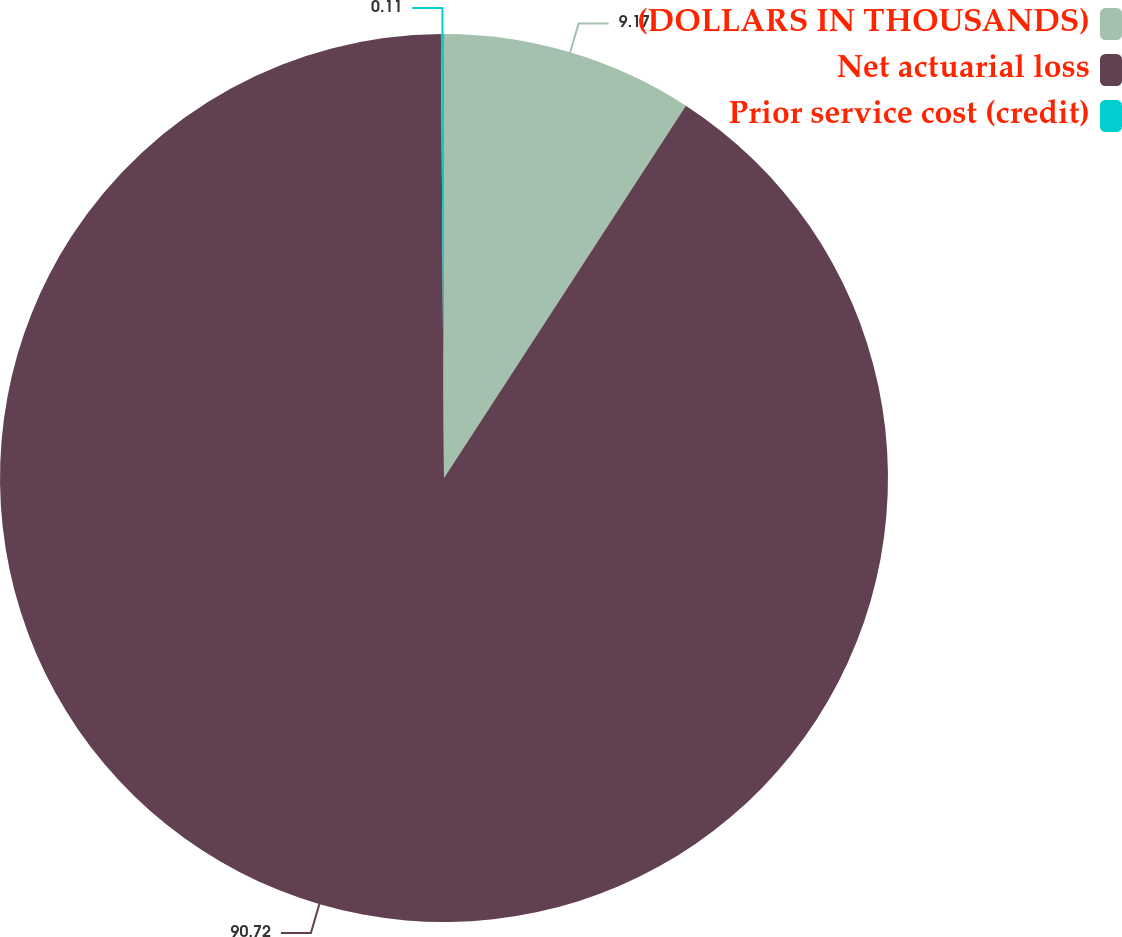Convert chart to OTSL. <chart><loc_0><loc_0><loc_500><loc_500><pie_chart><fcel>(DOLLARS IN THOUSANDS)<fcel>Net actuarial loss<fcel>Prior service cost (credit)<nl><fcel>9.17%<fcel>90.72%<fcel>0.11%<nl></chart> 